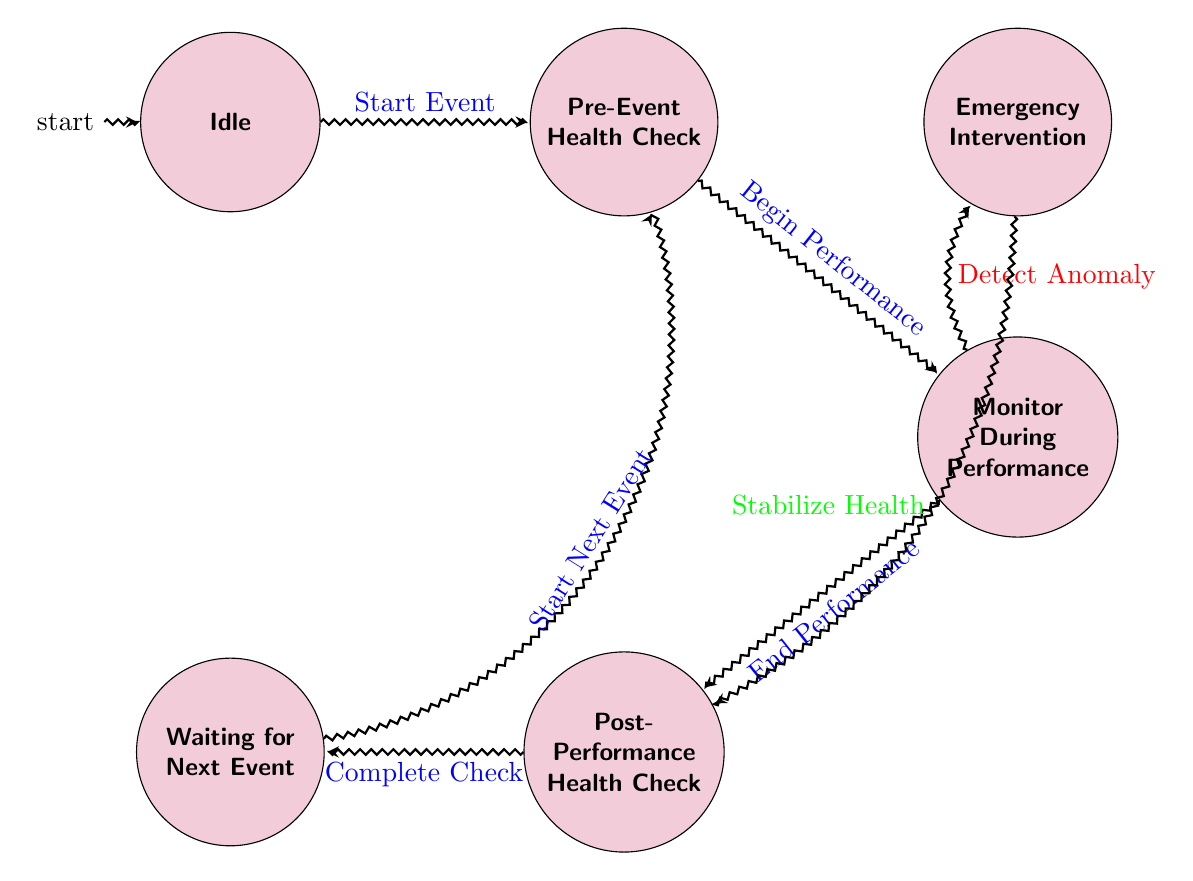What is the initial state of the diagram? The initial state is labeled "Idle", which is the first node in the diagram according to its definition.
Answer: Idle How many states are present in this finite state machine? There are a total of six states indicated in the diagram: Idle, Pre-Event Health Check, Monitor During Performance, Post-Performance Health Check, Waiting for Next Event, and Emergency Intervention.
Answer: 6 What action transitions occur after "Pre-Event Health Check"? The action that occurs after "Pre-Event Health Check" is "Begin Performance", moving to the "Monitor During Performance" state, as shown by the directed edge from pre to monitor.
Answer: Begin Performance Which state is entered after detecting an anomaly during performance? After detecting an anomaly during performance, the state transitioned to is "Emergency Intervention," as represented by the directed edge going from Monitor During Performance to Emergency Intervention.
Answer: Emergency Intervention What action follows after "Post-Performance Health Check"? The action that follows "Post-Performance Health Check" is "Complete Check," which leads to the "Waiting for Next Event" state, as depicted in the diagram.
Answer: Complete Check If in the "Monitor During Performance" state an anomaly is detected, what is the next action taken? The next action taken after detecting an anomaly in the "Monitor During Performance" state is "Stabilize Health," which leads to the "Post-Performance Health Check" state, according to the defined transitions.
Answer: Stabilize Health Where does the state "Waiting for Next Event" transition to? The state "Waiting for Next Event" transitions to "Pre-Event Health Check" when the action "Start Next Event" occurs, tracing the edge directed towards the pre state in the diagram.
Answer: Pre-Event Health Check What happens when the event is started from the idle state? When the event is started from the idle state, the transition moves to the "Pre-Event Health Check" state, as defined by the action "Start Event" from the idle node.
Answer: Pre-Event Health Check 